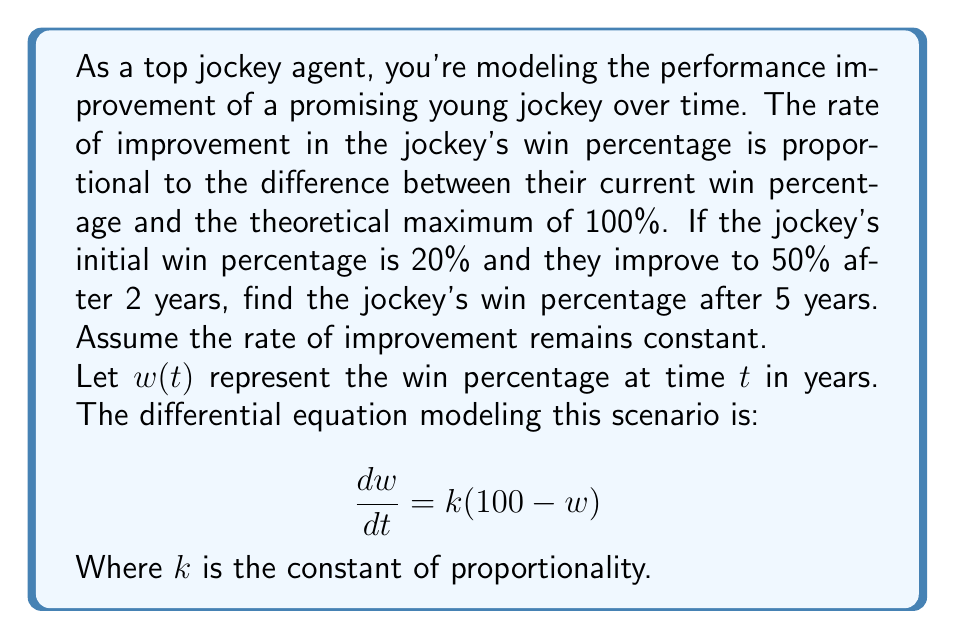Could you help me with this problem? Let's solve this problem step by step:

1) The given differential equation is:
   $$\frac{dw}{dt} = k(100 - w)$$

2) This is a separable equation. Rearranging it:
   $$\frac{dw}{100 - w} = k dt$$

3) Integrating both sides:
   $$-\ln|100 - w| = kt + C$$

4) Solving for $w$:
   $$w = 100 - Ae^{-kt}$$
   where $A = e^{-C}$ is a constant.

5) Using the initial condition $w(0) = 20$:
   $$20 = 100 - A$$
   $$A = 80$$

6) So our solution is:
   $$w = 100 - 80e^{-kt}$$

7) Using the condition $w(2) = 50$:
   $$50 = 100 - 80e^{-2k}$$
   $$80e^{-2k} = 50$$
   $$e^{-2k} = \frac{5}{8}$$
   $$-2k = \ln(\frac{5}{8})$$
   $$k = -\frac{1}{2}\ln(\frac{5}{8}) \approx 0.2231$$

8) Now we can find $w(5)$:
   $$w(5) = 100 - 80e^{-0.2231 * 5}$$
   $$w(5) = 100 - 80 * 0.3272$$
   $$w(5) = 73.82$$

Therefore, after 5 years, the jockey's win percentage will be approximately 73.82%.
Answer: 73.82% 